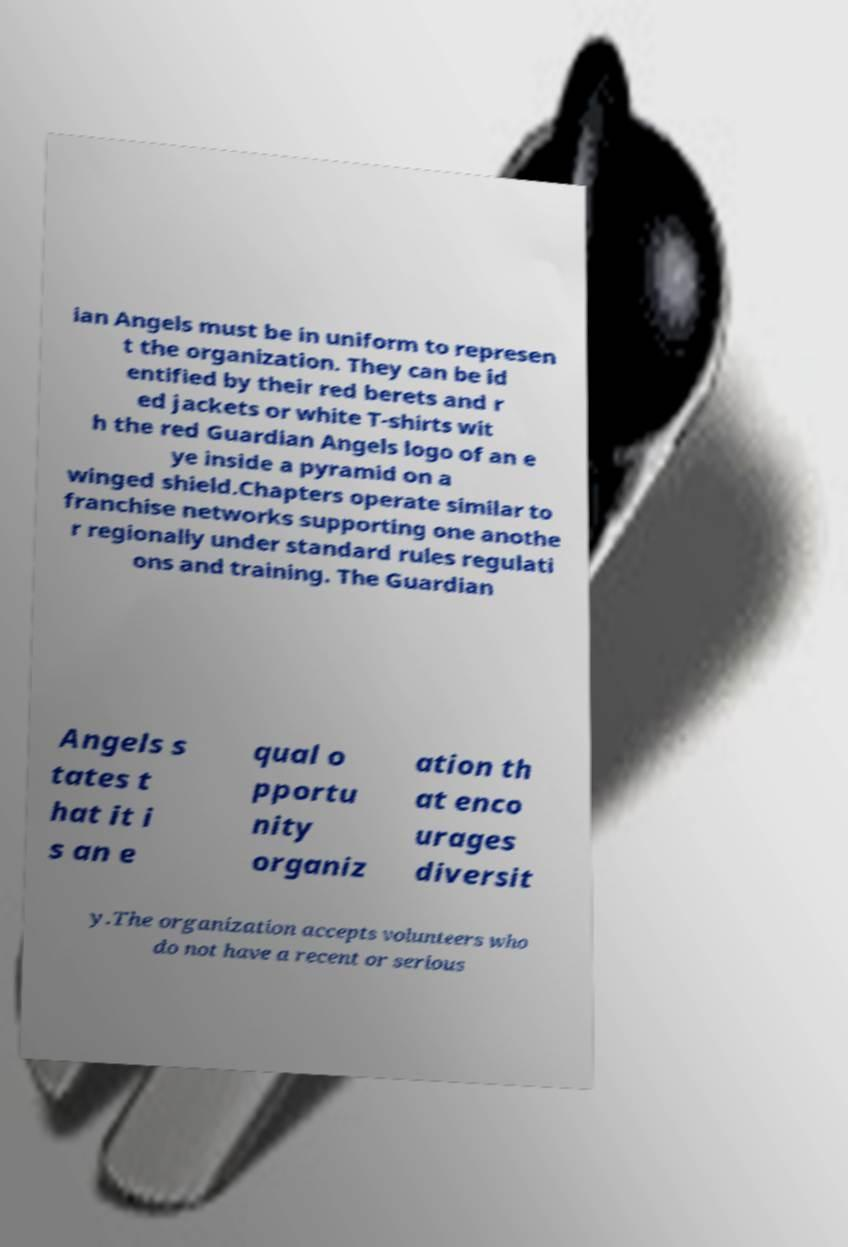There's text embedded in this image that I need extracted. Can you transcribe it verbatim? ian Angels must be in uniform to represen t the organization. They can be id entified by their red berets and r ed jackets or white T-shirts wit h the red Guardian Angels logo of an e ye inside a pyramid on a winged shield.Chapters operate similar to franchise networks supporting one anothe r regionally under standard rules regulati ons and training. The Guardian Angels s tates t hat it i s an e qual o pportu nity organiz ation th at enco urages diversit y.The organization accepts volunteers who do not have a recent or serious 